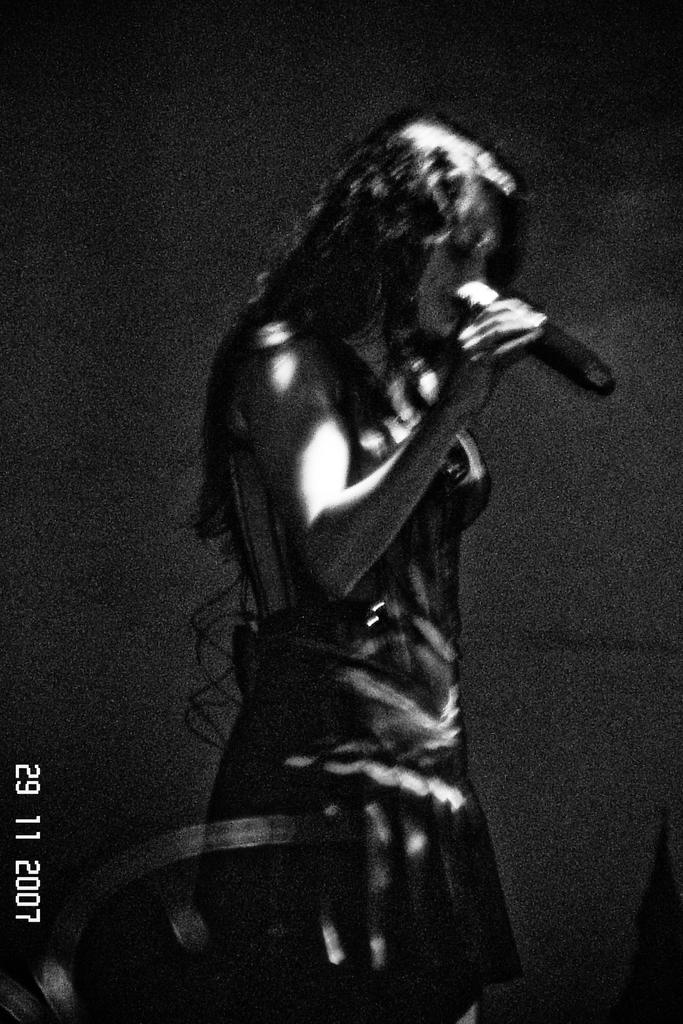What is the color scheme of the image? The image is black and white. Can you describe the person in the image? There is a person in the image, and they are holding a microphone. Is there any additional information or branding in the image? Yes, there is a watermark in the left side corner of the image. What type of holiday decoration can be seen in the image? There are no holiday decorations present in the image. Can you describe the cave in the image? There is no cave present in the image. What flavor of cracker is the person holding in the image? There is no cracker present in the image; the person is holding a microphone. 